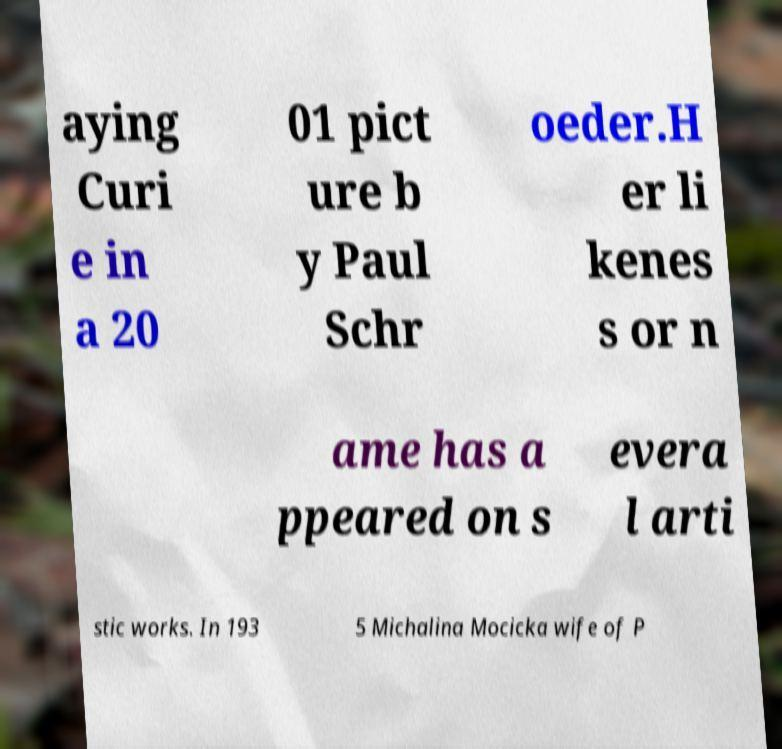Can you accurately transcribe the text from the provided image for me? aying Curi e in a 20 01 pict ure b y Paul Schr oeder.H er li kenes s or n ame has a ppeared on s evera l arti stic works. In 193 5 Michalina Mocicka wife of P 